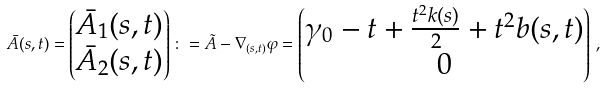<formula> <loc_0><loc_0><loc_500><loc_500>\bar { A } ( s , t ) = \begin{pmatrix} \bar { A } _ { 1 } ( s , t ) \\ \bar { A } _ { 2 } ( s , t ) \end{pmatrix} \colon = \tilde { A } - \nabla _ { ( s , t ) } \varphi = \begin{pmatrix} \gamma _ { 0 } - t + \frac { t ^ { 2 } k ( s ) } { 2 } + t ^ { 2 } b ( s , t ) \\ 0 \end{pmatrix} \, ,</formula> 